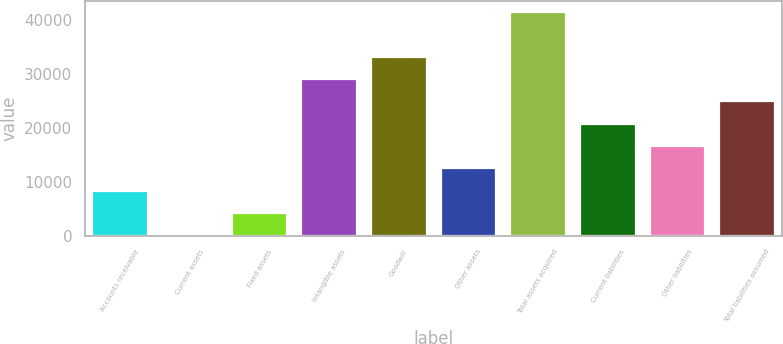Convert chart to OTSL. <chart><loc_0><loc_0><loc_500><loc_500><bar_chart><fcel>Accounts receivable<fcel>Current assets<fcel>Fixed assets<fcel>Intangible assets<fcel>Goodwill<fcel>Other assets<fcel>Total assets acquired<fcel>Current liabilities<fcel>Other liabilities<fcel>Total liabilities assumed<nl><fcel>8369<fcel>68<fcel>4218.5<fcel>29121.5<fcel>33272<fcel>12519.5<fcel>41573<fcel>20820.5<fcel>16670<fcel>24971<nl></chart> 